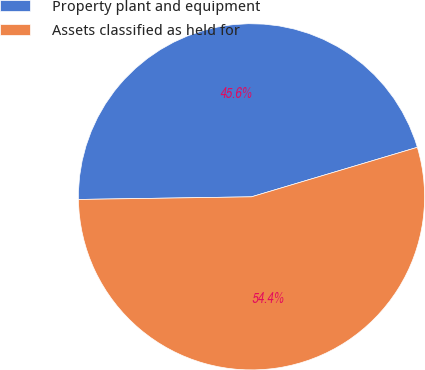Convert chart. <chart><loc_0><loc_0><loc_500><loc_500><pie_chart><fcel>Property plant and equipment<fcel>Assets classified as held for<nl><fcel>45.62%<fcel>54.37%<nl></chart> 